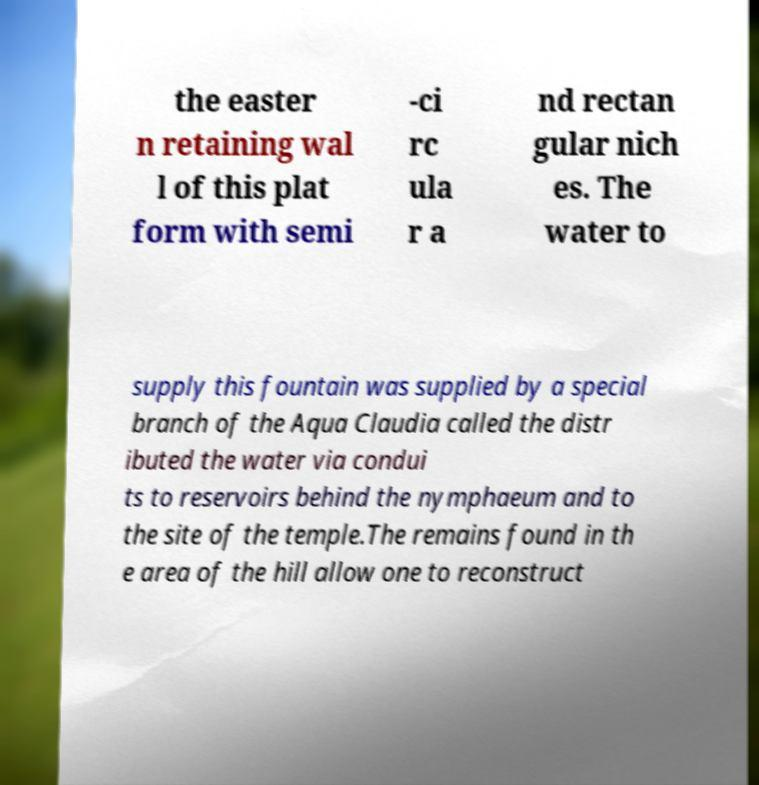Can you read and provide the text displayed in the image?This photo seems to have some interesting text. Can you extract and type it out for me? the easter n retaining wal l of this plat form with semi -ci rc ula r a nd rectan gular nich es. The water to supply this fountain was supplied by a special branch of the Aqua Claudia called the distr ibuted the water via condui ts to reservoirs behind the nymphaeum and to the site of the temple.The remains found in th e area of the hill allow one to reconstruct 